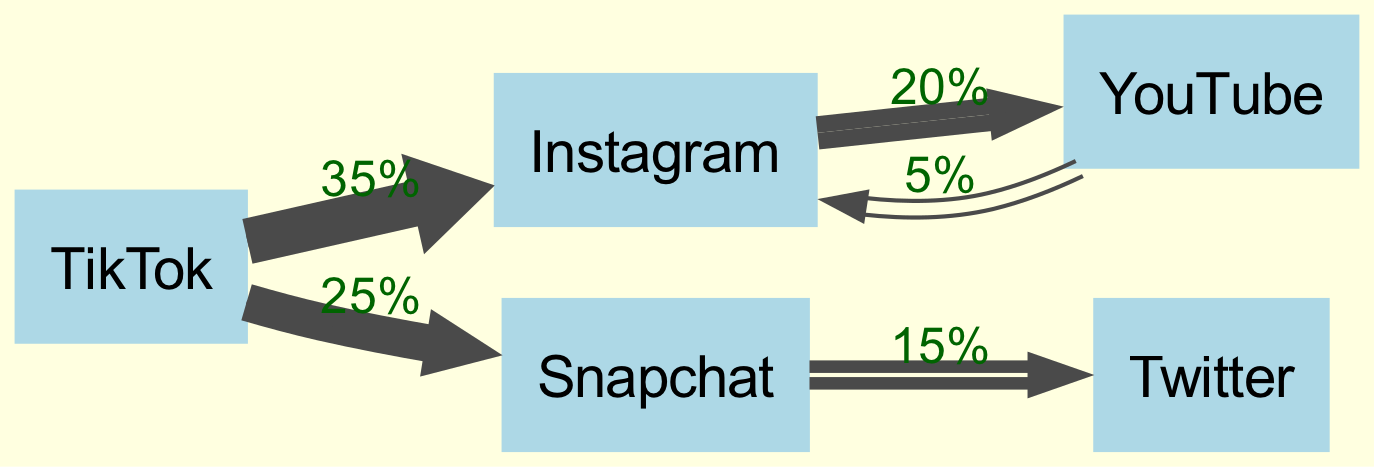What is the most time spent on a single platform? Reviewing the diagram, I look for the largest link value or node in percentages. TikTok has the highest percentage at 35%.
Answer: TikTok Which platform connects to Snapchat? From the links in the diagram, I can see that TikTok and Twitter connect to Snapchat. To answer this, either can be stated, but typically the first connection listed is preferred.
Answer: TikTok How many platforms are displayed in the diagram? Counting the nodes in the diagram, there are five platforms represented: TikTok, Instagram, Snapchat, YouTube, and Twitter.
Answer: 5 What percentage of Snapchat users switch to Twitter? Looking at the link from Snapchat to Twitter, the value indicated for this transition is 15%.
Answer: 15% Which platform has the least flow percentage into Instagram? Examining the diagram, the connections into Instagram are from TikTok (35%), YouTube (5%), indicating that YouTube has the least flow at 5%.
Answer: YouTube Does any platform direct flow back to TikTok? In a Sankey diagram, flow typically represents a one-way direction; reviewing the links, it appears no platform directs back to TikTok.
Answer: No What is the total percentage flow from TikTok? The total flow from TikTok goes to Instagram (35%) and Snapchat (25%). Adding these values gives 60% total flow out of TikTok.
Answer: 60% Which platform has two outgoing connections in the diagram? Analyzing the links, I find that TikTok has outgoing connections to both Instagram and Snapchat, making it the platform with two outgoing connections.
Answer: TikTok 